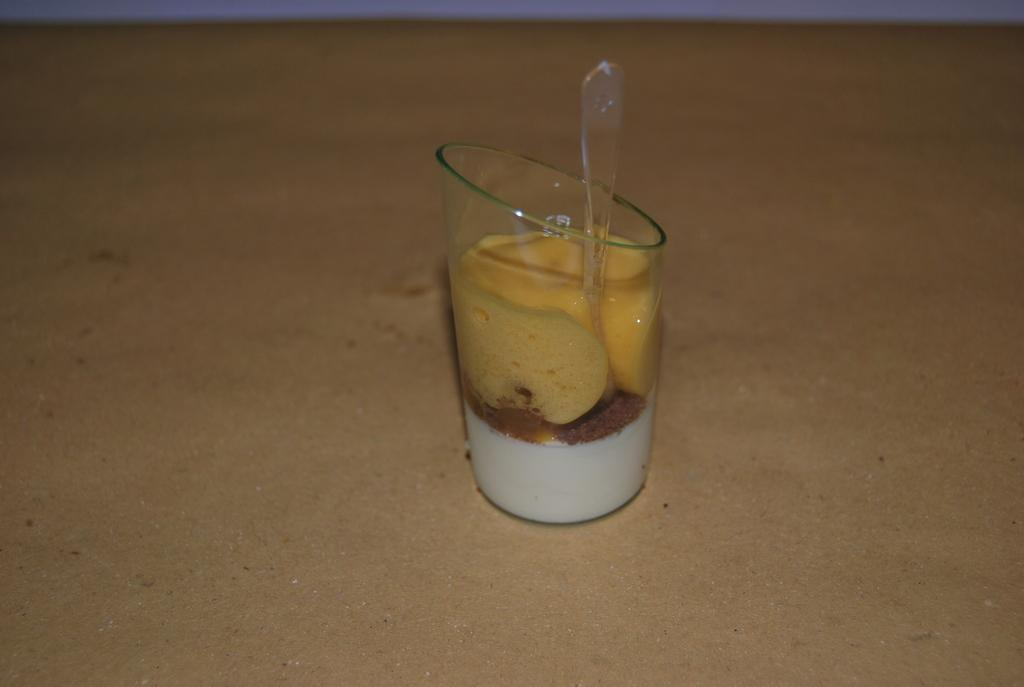What is present in the image that can hold liquid? There is a glass in the image. What can be seen inside the glass? There are objects of yellow and white color in the glass. What utensil is present in the glass? There is a spoon in the glass. What type of behavior can be observed in the shop in the image? There is no shop present in the image, so it is not possible to observe any behavior in a shop. 